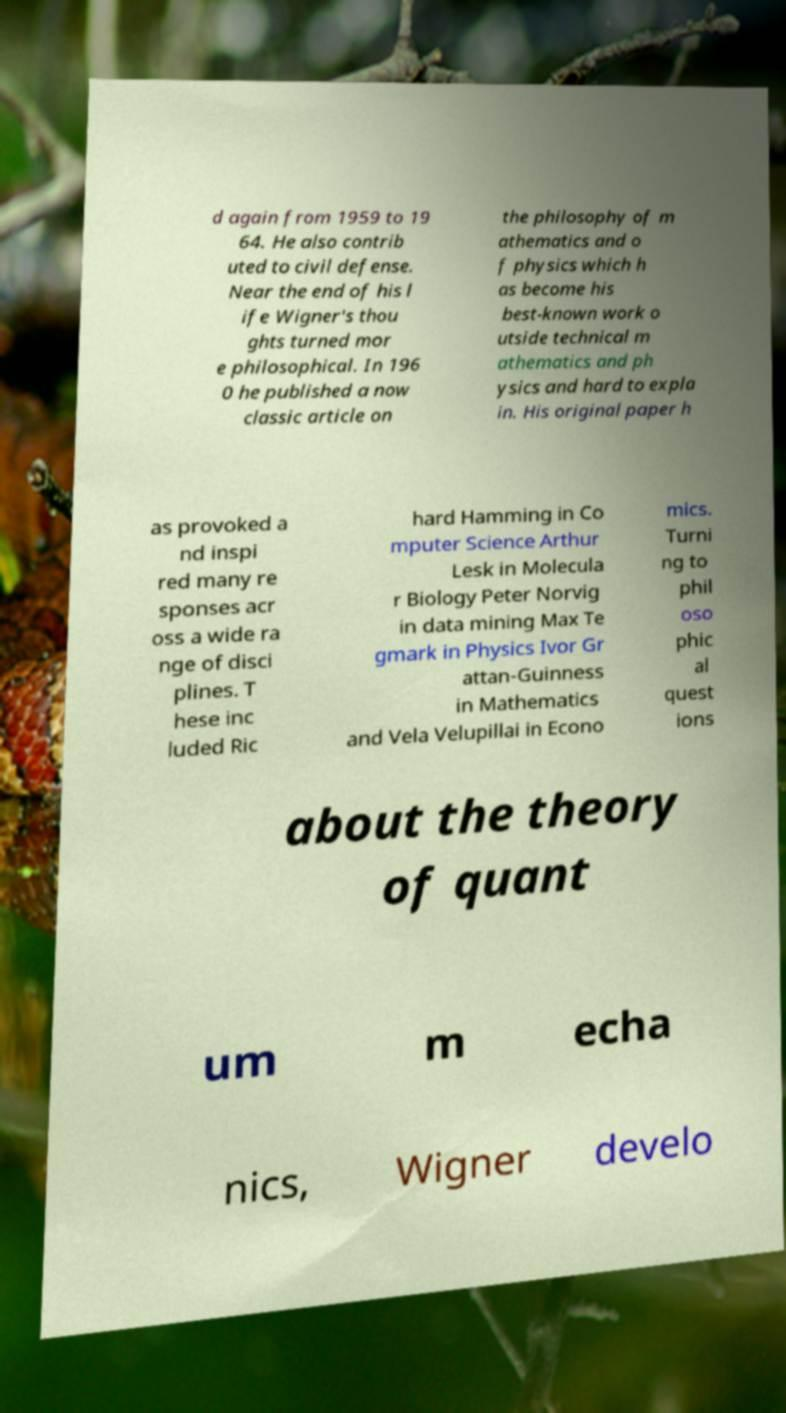What messages or text are displayed in this image? I need them in a readable, typed format. d again from 1959 to 19 64. He also contrib uted to civil defense. Near the end of his l ife Wigner's thou ghts turned mor e philosophical. In 196 0 he published a now classic article on the philosophy of m athematics and o f physics which h as become his best-known work o utside technical m athematics and ph ysics and hard to expla in. His original paper h as provoked a nd inspi red many re sponses acr oss a wide ra nge of disci plines. T hese inc luded Ric hard Hamming in Co mputer Science Arthur Lesk in Molecula r Biology Peter Norvig in data mining Max Te gmark in Physics Ivor Gr attan-Guinness in Mathematics and Vela Velupillai in Econo mics. Turni ng to phil oso phic al quest ions about the theory of quant um m echa nics, Wigner develo 